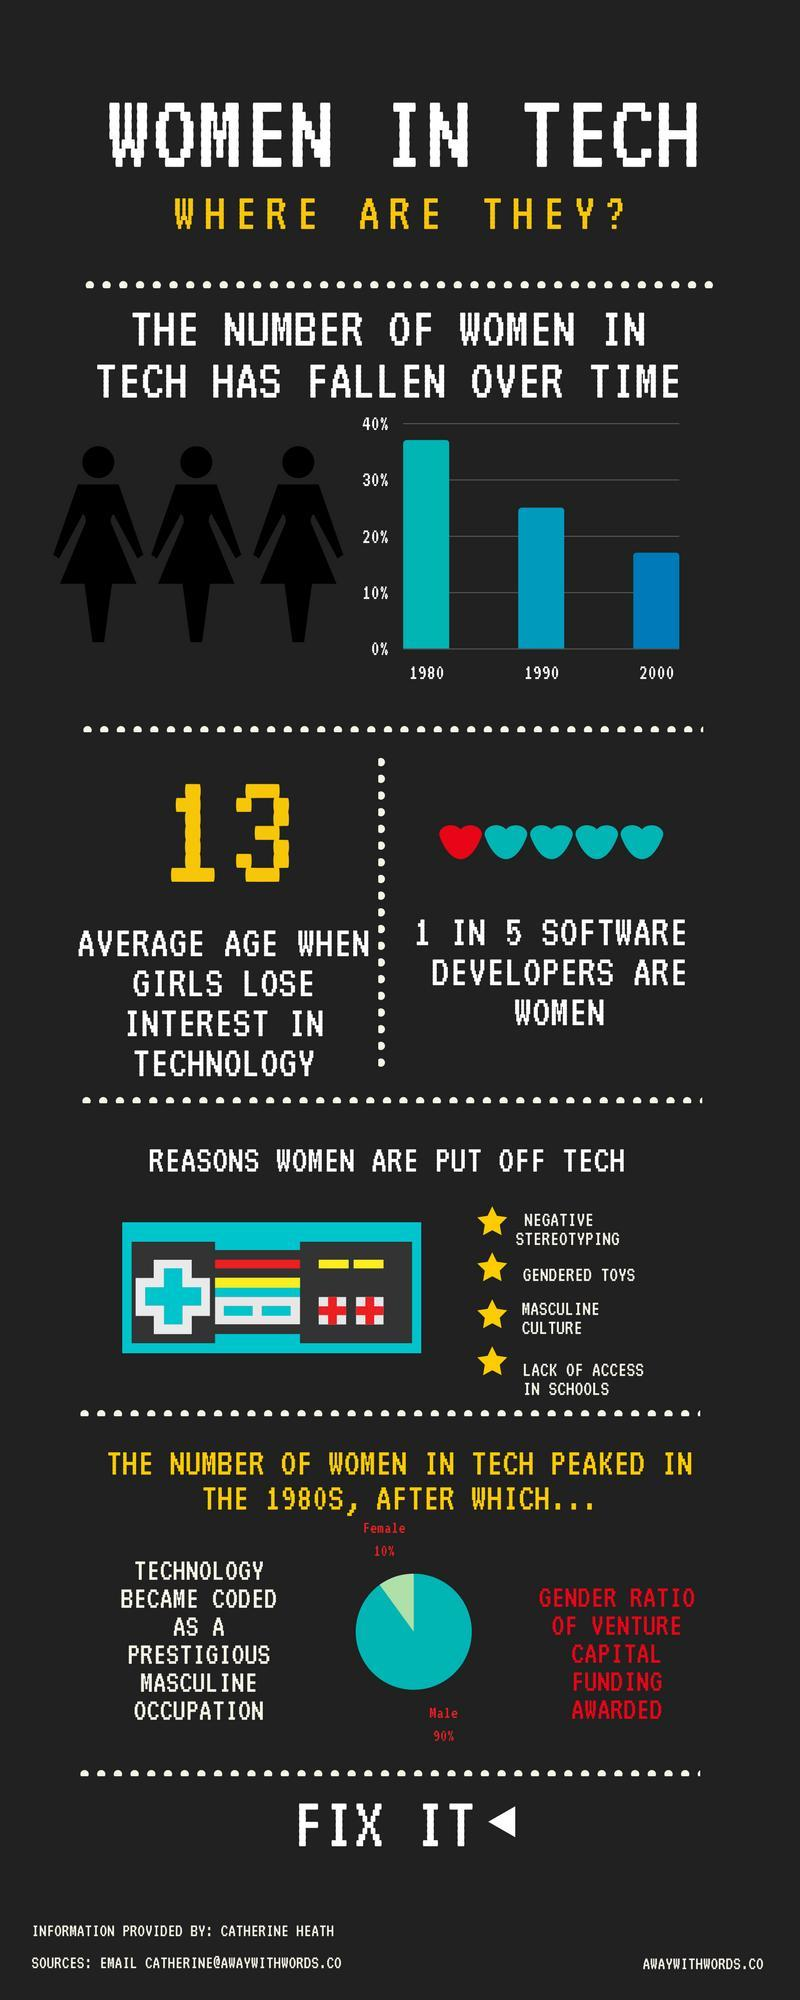What percentage of women were awarded venture capital funding?
Answer the question with a short phrase. 10% What is the average age when girls lose interest in technology? 13 